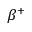Convert formula to latex. <formula><loc_0><loc_0><loc_500><loc_500>\beta ^ { + }</formula> 